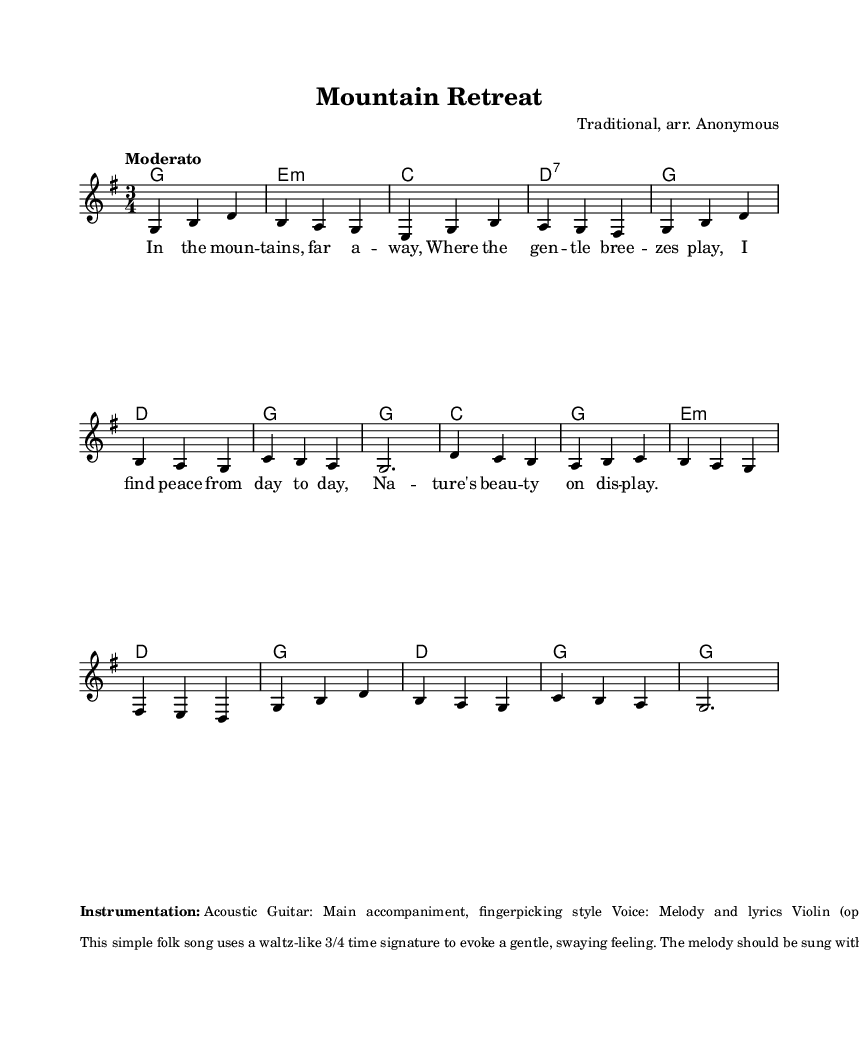What is the key signature of this music? The key signature is G major, which has one sharp (F#). It is indicated at the beginning of the staff with a sharp sign on the top line of the staff.
Answer: G major What is the time signature of this music? The time signature is 3/4, which indicates three quarter-note beats per measure. It is displayed at the beginning of the score, next to the key signature.
Answer: 3/4 What tempo marking is indicated for this piece? The tempo marking is "Moderato," which suggests a moderate pace for the piece. This marking is typically found at the beginning of the score, signaling how the music should be played.
Answer: Moderato What is the first chord in the song? The first chord is G major, which is represented by the letter G in the chord names section. This chord provides the harmonic foundation at the start of the piece.
Answer: G How many measures are there in the melody? The melody consists of eleven measures. By counting the measures from the beginning to the end of the melody line, we arrive at this total.
Answer: Eleven What style of instrumentation is specified for the guitar? The guitar is specified to use a fingerpicking style for the accompaniment. This is mentioned under the instrumentation section, indicating how the guitar should be played to complement the melody.
Answer: Fingerpicking How does the accompaniment embellish the overall piece? The guitar's fingerpicking pattern creates a flowing, stream-like quality, enhancing the piece's tranquil nature theme. This is described in the analysis of the music, illustrating how the accompaniment fits the mood.
Answer: Flowing, stream-like quality 